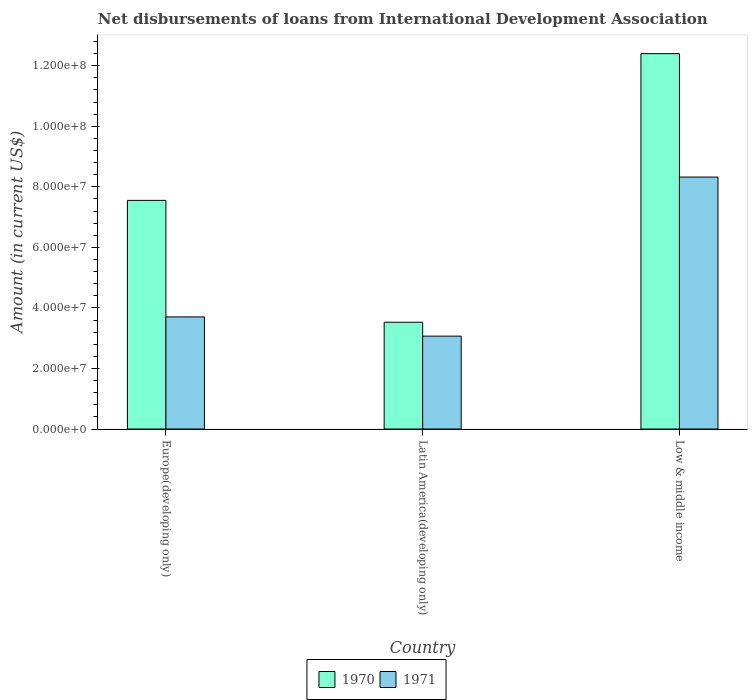How many groups of bars are there?
Provide a succinct answer. 3. Are the number of bars on each tick of the X-axis equal?
Your answer should be compact. Yes. What is the label of the 2nd group of bars from the left?
Give a very brief answer. Latin America(developing only). In how many cases, is the number of bars for a given country not equal to the number of legend labels?
Make the answer very short. 0. What is the amount of loans disbursed in 1970 in Low & middle income?
Your answer should be very brief. 1.24e+08. Across all countries, what is the maximum amount of loans disbursed in 1971?
Offer a very short reply. 8.32e+07. Across all countries, what is the minimum amount of loans disbursed in 1970?
Your response must be concise. 3.53e+07. In which country was the amount of loans disbursed in 1970 minimum?
Provide a succinct answer. Latin America(developing only). What is the total amount of loans disbursed in 1971 in the graph?
Your response must be concise. 1.51e+08. What is the difference between the amount of loans disbursed in 1971 in Latin America(developing only) and that in Low & middle income?
Keep it short and to the point. -5.25e+07. What is the difference between the amount of loans disbursed in 1971 in Latin America(developing only) and the amount of loans disbursed in 1970 in Europe(developing only)?
Offer a very short reply. -4.48e+07. What is the average amount of loans disbursed in 1970 per country?
Your answer should be compact. 7.83e+07. What is the difference between the amount of loans disbursed of/in 1971 and amount of loans disbursed of/in 1970 in Low & middle income?
Provide a succinct answer. -4.08e+07. In how many countries, is the amount of loans disbursed in 1970 greater than 88000000 US$?
Ensure brevity in your answer.  1. What is the ratio of the amount of loans disbursed in 1971 in Europe(developing only) to that in Latin America(developing only)?
Your response must be concise. 1.21. What is the difference between the highest and the second highest amount of loans disbursed in 1971?
Ensure brevity in your answer.  4.62e+07. What is the difference between the highest and the lowest amount of loans disbursed in 1971?
Your response must be concise. 5.25e+07. In how many countries, is the amount of loans disbursed in 1971 greater than the average amount of loans disbursed in 1971 taken over all countries?
Provide a short and direct response. 1. Is the sum of the amount of loans disbursed in 1970 in Europe(developing only) and Latin America(developing only) greater than the maximum amount of loans disbursed in 1971 across all countries?
Offer a terse response. Yes. How many bars are there?
Offer a very short reply. 6. Where does the legend appear in the graph?
Your answer should be compact. Bottom center. What is the title of the graph?
Offer a very short reply. Net disbursements of loans from International Development Association. Does "1980" appear as one of the legend labels in the graph?
Provide a succinct answer. No. What is the label or title of the X-axis?
Your answer should be compact. Country. What is the label or title of the Y-axis?
Your answer should be compact. Amount (in current US$). What is the Amount (in current US$) in 1970 in Europe(developing only)?
Provide a succinct answer. 7.55e+07. What is the Amount (in current US$) in 1971 in Europe(developing only)?
Offer a terse response. 3.70e+07. What is the Amount (in current US$) of 1970 in Latin America(developing only)?
Give a very brief answer. 3.53e+07. What is the Amount (in current US$) in 1971 in Latin America(developing only)?
Provide a succinct answer. 3.07e+07. What is the Amount (in current US$) of 1970 in Low & middle income?
Provide a short and direct response. 1.24e+08. What is the Amount (in current US$) of 1971 in Low & middle income?
Make the answer very short. 8.32e+07. Across all countries, what is the maximum Amount (in current US$) in 1970?
Offer a very short reply. 1.24e+08. Across all countries, what is the maximum Amount (in current US$) of 1971?
Your answer should be very brief. 8.32e+07. Across all countries, what is the minimum Amount (in current US$) of 1970?
Offer a terse response. 3.53e+07. Across all countries, what is the minimum Amount (in current US$) of 1971?
Give a very brief answer. 3.07e+07. What is the total Amount (in current US$) of 1970 in the graph?
Provide a succinct answer. 2.35e+08. What is the total Amount (in current US$) of 1971 in the graph?
Provide a short and direct response. 1.51e+08. What is the difference between the Amount (in current US$) of 1970 in Europe(developing only) and that in Latin America(developing only)?
Make the answer very short. 4.03e+07. What is the difference between the Amount (in current US$) in 1971 in Europe(developing only) and that in Latin America(developing only)?
Your response must be concise. 6.35e+06. What is the difference between the Amount (in current US$) in 1970 in Europe(developing only) and that in Low & middle income?
Provide a succinct answer. -4.85e+07. What is the difference between the Amount (in current US$) of 1971 in Europe(developing only) and that in Low & middle income?
Your answer should be very brief. -4.62e+07. What is the difference between the Amount (in current US$) of 1970 in Latin America(developing only) and that in Low & middle income?
Provide a short and direct response. -8.87e+07. What is the difference between the Amount (in current US$) of 1971 in Latin America(developing only) and that in Low & middle income?
Provide a short and direct response. -5.25e+07. What is the difference between the Amount (in current US$) in 1970 in Europe(developing only) and the Amount (in current US$) in 1971 in Latin America(developing only)?
Provide a succinct answer. 4.48e+07. What is the difference between the Amount (in current US$) of 1970 in Europe(developing only) and the Amount (in current US$) of 1971 in Low & middle income?
Provide a succinct answer. -7.70e+06. What is the difference between the Amount (in current US$) of 1970 in Latin America(developing only) and the Amount (in current US$) of 1971 in Low & middle income?
Ensure brevity in your answer.  -4.80e+07. What is the average Amount (in current US$) in 1970 per country?
Keep it short and to the point. 7.83e+07. What is the average Amount (in current US$) in 1971 per country?
Offer a terse response. 5.03e+07. What is the difference between the Amount (in current US$) of 1970 and Amount (in current US$) of 1971 in Europe(developing only)?
Provide a succinct answer. 3.85e+07. What is the difference between the Amount (in current US$) in 1970 and Amount (in current US$) in 1971 in Latin America(developing only)?
Make the answer very short. 4.59e+06. What is the difference between the Amount (in current US$) in 1970 and Amount (in current US$) in 1971 in Low & middle income?
Your answer should be compact. 4.08e+07. What is the ratio of the Amount (in current US$) in 1970 in Europe(developing only) to that in Latin America(developing only)?
Provide a succinct answer. 2.14. What is the ratio of the Amount (in current US$) of 1971 in Europe(developing only) to that in Latin America(developing only)?
Offer a terse response. 1.21. What is the ratio of the Amount (in current US$) of 1970 in Europe(developing only) to that in Low & middle income?
Ensure brevity in your answer.  0.61. What is the ratio of the Amount (in current US$) of 1971 in Europe(developing only) to that in Low & middle income?
Your answer should be compact. 0.44. What is the ratio of the Amount (in current US$) in 1970 in Latin America(developing only) to that in Low & middle income?
Offer a very short reply. 0.28. What is the ratio of the Amount (in current US$) of 1971 in Latin America(developing only) to that in Low & middle income?
Keep it short and to the point. 0.37. What is the difference between the highest and the second highest Amount (in current US$) of 1970?
Your answer should be compact. 4.85e+07. What is the difference between the highest and the second highest Amount (in current US$) of 1971?
Provide a succinct answer. 4.62e+07. What is the difference between the highest and the lowest Amount (in current US$) in 1970?
Give a very brief answer. 8.87e+07. What is the difference between the highest and the lowest Amount (in current US$) of 1971?
Your response must be concise. 5.25e+07. 